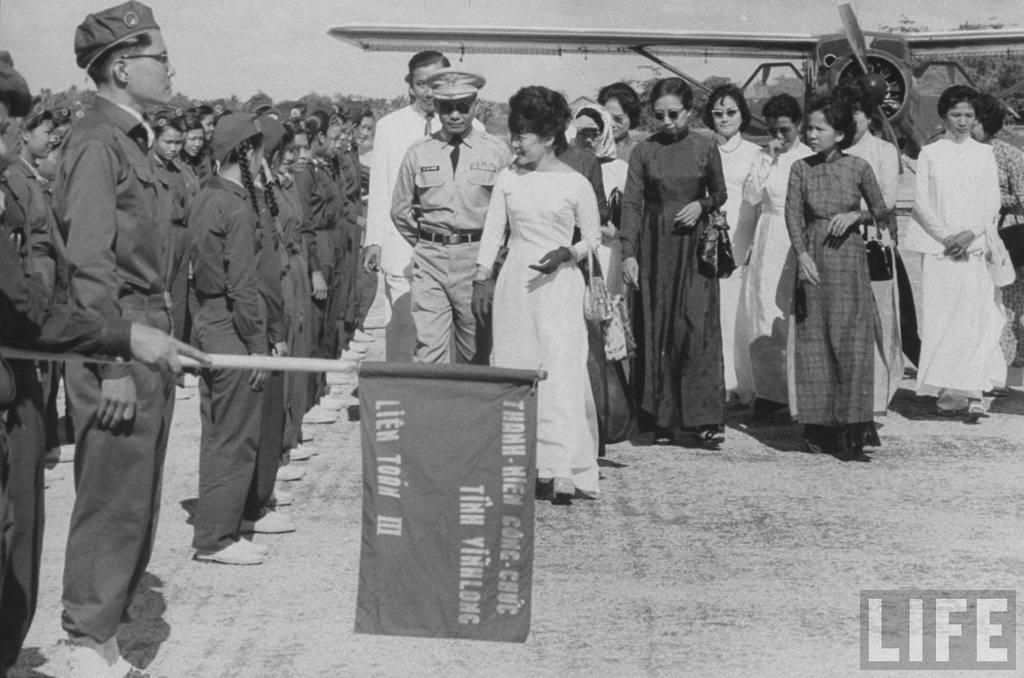What company is this picture associated with?
Your answer should be very brief. Life. What roman numeral is on the flag?
Provide a short and direct response. Iii. 